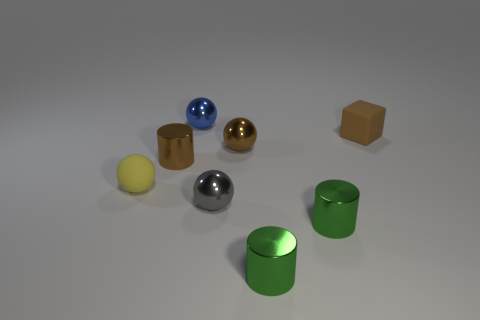The brown thing to the left of the brown shiny object on the right side of the ball behind the block is made of what material?
Ensure brevity in your answer.  Metal. Do the small brown metal thing that is on the right side of the tiny blue thing and the yellow matte object have the same shape?
Make the answer very short. Yes. What is the ball behind the brown metallic ball made of?
Provide a succinct answer. Metal. How many shiny objects are either large purple things or blue spheres?
Provide a short and direct response. 1. Are there any cylinders of the same size as the gray sphere?
Keep it short and to the point. Yes. Are there more green metallic cylinders that are in front of the brown matte cube than green things?
Offer a very short reply. No. How many large things are either gray metallic things or cyan metallic cylinders?
Give a very brief answer. 0. What number of small gray metal objects have the same shape as the blue metallic thing?
Keep it short and to the point. 1. What is the cylinder left of the small shiny thing behind the brown metal sphere made of?
Your answer should be compact. Metal. What size is the matte thing that is on the right side of the small blue metallic object?
Keep it short and to the point. Small. 